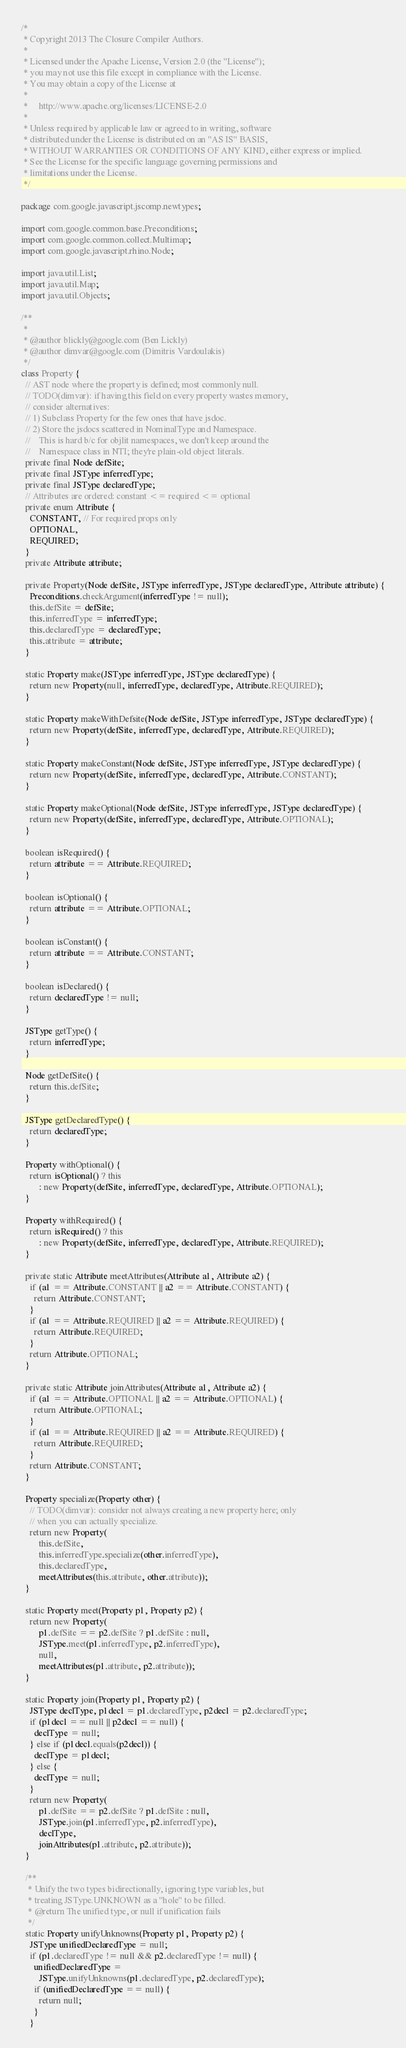Convert code to text. <code><loc_0><loc_0><loc_500><loc_500><_Java_>/*
 * Copyright 2013 The Closure Compiler Authors.
 *
 * Licensed under the Apache License, Version 2.0 (the "License");
 * you may not use this file except in compliance with the License.
 * You may obtain a copy of the License at
 *
 *     http://www.apache.org/licenses/LICENSE-2.0
 *
 * Unless required by applicable law or agreed to in writing, software
 * distributed under the License is distributed on an "AS IS" BASIS,
 * WITHOUT WARRANTIES OR CONDITIONS OF ANY KIND, either express or implied.
 * See the License for the specific language governing permissions and
 * limitations under the License.
 */

package com.google.javascript.jscomp.newtypes;

import com.google.common.base.Preconditions;
import com.google.common.collect.Multimap;
import com.google.javascript.rhino.Node;

import java.util.List;
import java.util.Map;
import java.util.Objects;

/**
 *
 * @author blickly@google.com (Ben Lickly)
 * @author dimvar@google.com (Dimitris Vardoulakis)
 */
class Property {
  // AST node where the property is defined; most commonly null.
  // TODO(dimvar): if having this field on every property wastes memory,
  // consider alternatives:
  // 1) Subclass Property for the few ones that have jsdoc.
  // 2) Store the jsdocs scattered in NominalType and Namespace.
  //    This is hard b/c for objlit namespaces, we don't keep around the
  //    Namespace class in NTI; they're plain-old object literals.
  private final Node defSite;
  private final JSType inferredType;
  private final JSType declaredType;
  // Attributes are ordered: constant <= required <= optional
  private enum Attribute {
    CONSTANT, // For required props only
    OPTIONAL,
    REQUIRED;
  }
  private Attribute attribute;

  private Property(Node defSite, JSType inferredType, JSType declaredType, Attribute attribute) {
    Preconditions.checkArgument(inferredType != null);
    this.defSite = defSite;
    this.inferredType = inferredType;
    this.declaredType = declaredType;
    this.attribute = attribute;
  }

  static Property make(JSType inferredType, JSType declaredType) {
    return new Property(null, inferredType, declaredType, Attribute.REQUIRED);
  }

  static Property makeWithDefsite(Node defSite, JSType inferredType, JSType declaredType) {
    return new Property(defSite, inferredType, declaredType, Attribute.REQUIRED);
  }

  static Property makeConstant(Node defSite, JSType inferredType, JSType declaredType) {
    return new Property(defSite, inferredType, declaredType, Attribute.CONSTANT);
  }

  static Property makeOptional(Node defSite, JSType inferredType, JSType declaredType) {
    return new Property(defSite, inferredType, declaredType, Attribute.OPTIONAL);
  }

  boolean isRequired() {
    return attribute == Attribute.REQUIRED;
  }

  boolean isOptional() {
    return attribute == Attribute.OPTIONAL;
  }

  boolean isConstant() {
    return attribute == Attribute.CONSTANT;
  }

  boolean isDeclared() {
    return declaredType != null;
  }

  JSType getType() {
    return inferredType;
  }

  Node getDefSite() {
    return this.defSite;
  }

  JSType getDeclaredType() {
    return declaredType;
  }

  Property withOptional() {
    return isOptional() ? this
        : new Property(defSite, inferredType, declaredType, Attribute.OPTIONAL);
  }

  Property withRequired() {
    return isRequired() ? this
        : new Property(defSite, inferredType, declaredType, Attribute.REQUIRED);
  }

  private static Attribute meetAttributes(Attribute a1, Attribute a2) {
    if (a1 == Attribute.CONSTANT || a2 == Attribute.CONSTANT) {
      return Attribute.CONSTANT;
    }
    if (a1 == Attribute.REQUIRED || a2 == Attribute.REQUIRED) {
      return Attribute.REQUIRED;
    }
    return Attribute.OPTIONAL;
  }

  private static Attribute joinAttributes(Attribute a1, Attribute a2) {
    if (a1 == Attribute.OPTIONAL || a2 == Attribute.OPTIONAL) {
      return Attribute.OPTIONAL;
    }
    if (a1 == Attribute.REQUIRED || a2 == Attribute.REQUIRED) {
      return Attribute.REQUIRED;
    }
    return Attribute.CONSTANT;
  }

  Property specialize(Property other) {
    // TODO(dimvar): consider not always creating a new property here; only
    // when you can actually specialize.
    return new Property(
        this.defSite,
        this.inferredType.specialize(other.inferredType),
        this.declaredType,
        meetAttributes(this.attribute, other.attribute));
  }

  static Property meet(Property p1, Property p2) {
    return new Property(
        p1.defSite == p2.defSite ? p1.defSite : null,
        JSType.meet(p1.inferredType, p2.inferredType),
        null,
        meetAttributes(p1.attribute, p2.attribute));
  }

  static Property join(Property p1, Property p2) {
    JSType declType, p1decl = p1.declaredType, p2decl = p2.declaredType;
    if (p1decl == null || p2decl == null) {
      declType = null;
    } else if (p1decl.equals(p2decl)) {
      declType = p1decl;
    } else {
      declType = null;
    }
    return new Property(
        p1.defSite == p2.defSite ? p1.defSite : null,
        JSType.join(p1.inferredType, p2.inferredType),
        declType,
        joinAttributes(p1.attribute, p2.attribute));
  }

  /**
   * Unify the two types bidirectionally, ignoring type variables, but
   * treating JSType.UNKNOWN as a "hole" to be filled.
   * @return The unified type, or null if unification fails
   */
  static Property unifyUnknowns(Property p1, Property p2) {
    JSType unifiedDeclaredType = null;
    if (p1.declaredType != null && p2.declaredType != null) {
      unifiedDeclaredType =
        JSType.unifyUnknowns(p1.declaredType, p2.declaredType);
      if (unifiedDeclaredType == null) {
        return null;
      }
    }</code> 